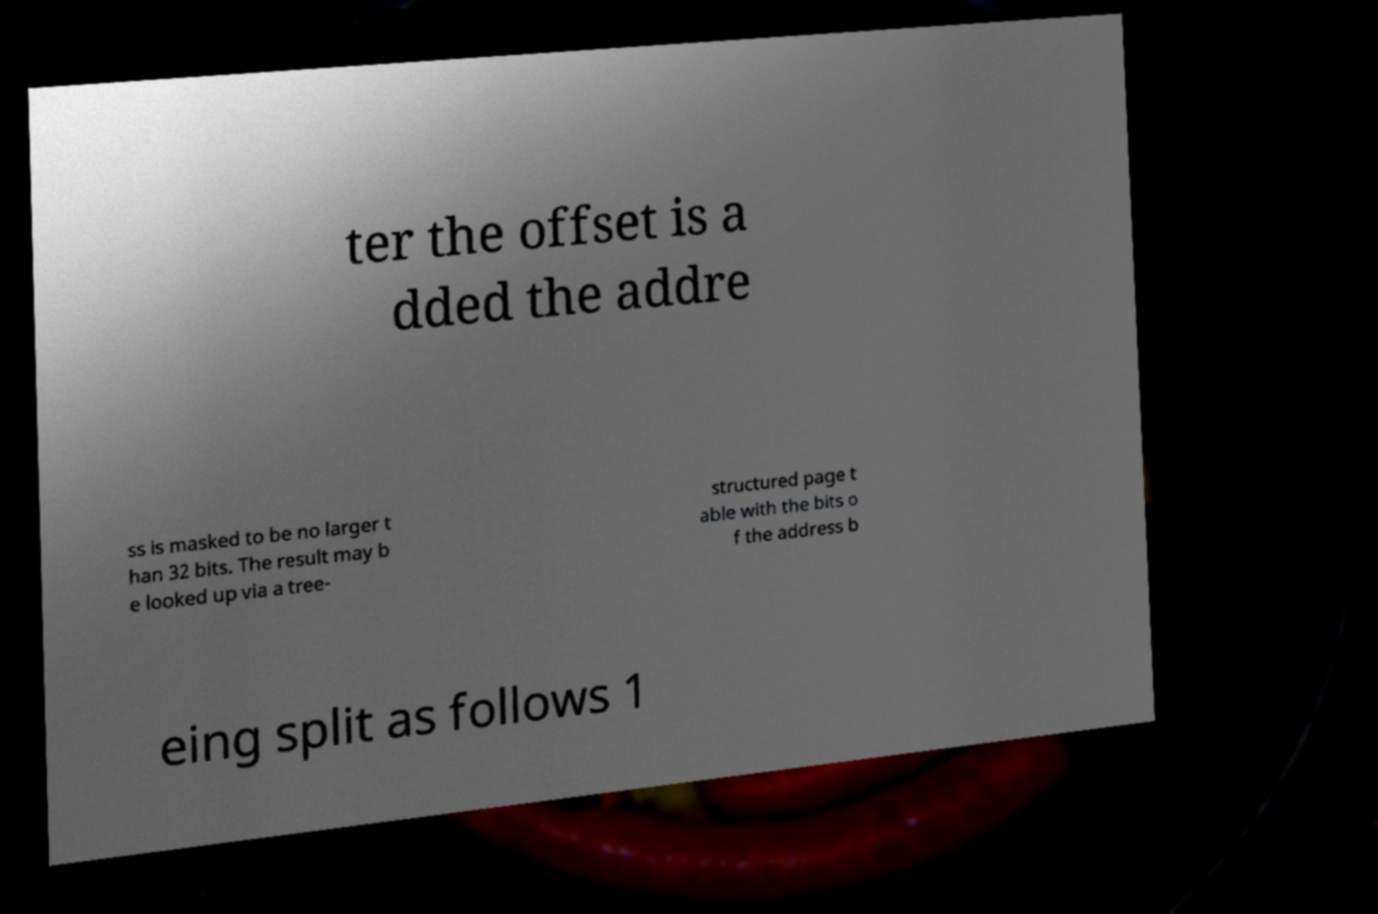Could you extract and type out the text from this image? ter the offset is a dded the addre ss is masked to be no larger t han 32 bits. The result may b e looked up via a tree- structured page t able with the bits o f the address b eing split as follows 1 